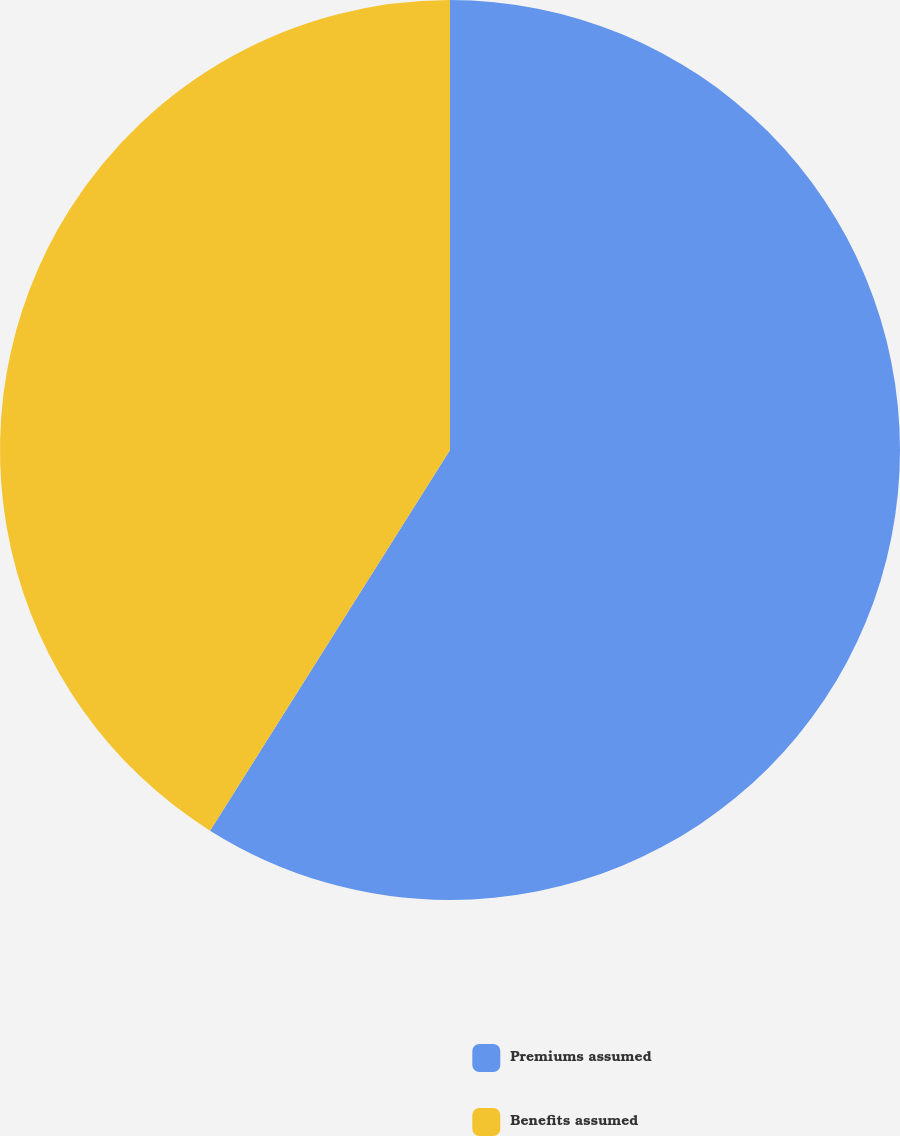<chart> <loc_0><loc_0><loc_500><loc_500><pie_chart><fcel>Premiums assumed<fcel>Benefits assumed<nl><fcel>58.95%<fcel>41.05%<nl></chart> 